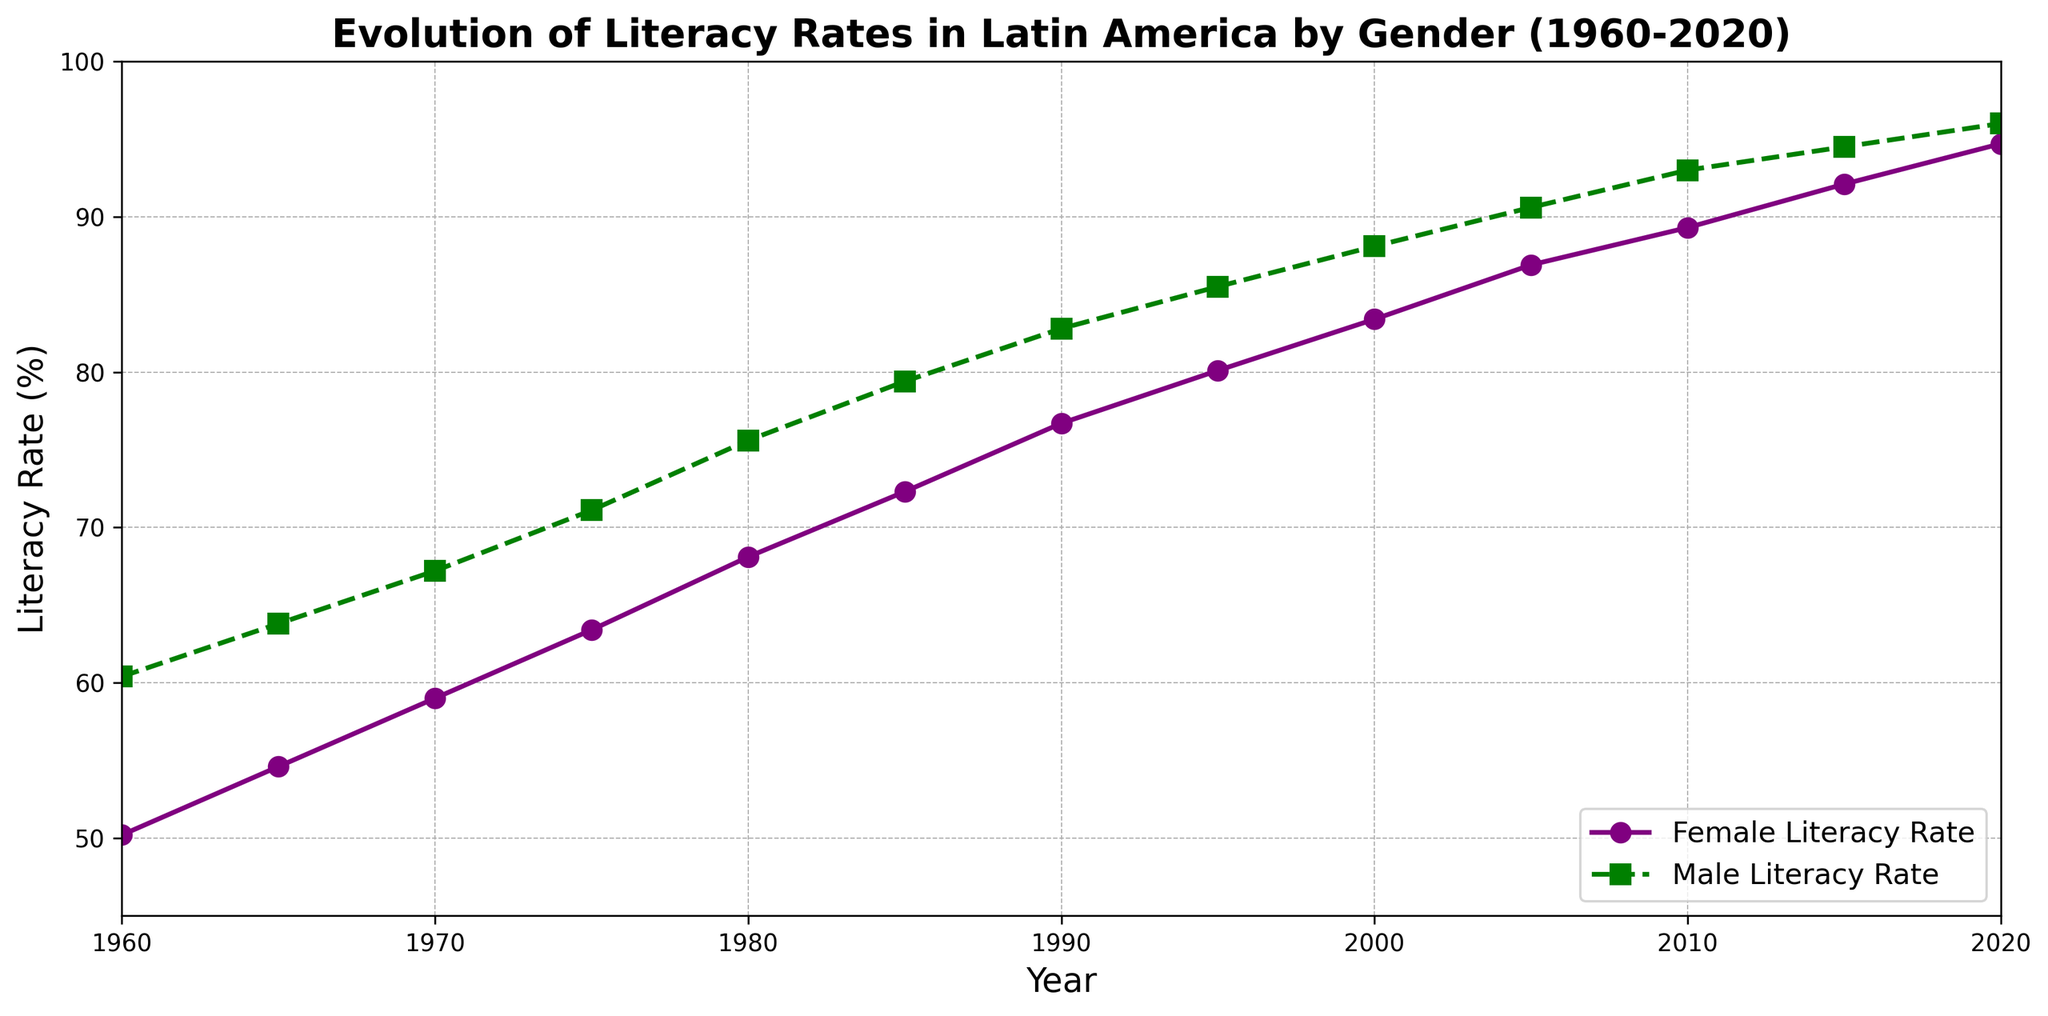What is the literacy rate gap between males and females in 1960? To find the literacy gap, subtract the female literacy rate from the male literacy rate in 1960. That is 60.4% - 50.2% = 10.2%.
Answer: 10.2% Which gender had a higher literacy rate in 1985, and by how much? Compare the literacy rates for males and females in 1985. The male literacy rate is 79.4% and the female literacy rate is 72.3%. Subtract the female rate from the male rate: 79.4% - 72.3% = 7.1%. Males had a higher rate by 7.1%.
Answer: Males by 7.1% How did the female literacy rate change from 2000 to 2010? Subtract the female literacy rate in 2000 from the rate in 2010. That is 89.3% - 83.4% = 5.9%.
Answer: Increased by 5.9% What was the average literacy rate for females in 1965 and 1970? Sum the female literacy rates for 1965 and 1970 and then divide by 2: (54.6% + 59.0%) / 2 = 56.8%.
Answer: 56.8% Between which consecutive years did male literacy rate increase the most? Look at the differences between consecutive years for the male literacy rate and find the maximum: 
(63.8% - 60.4% = 3.4% from 1960-1965, 
67.2% - 63.8% = 3.4% from 1965-1970, 
71.1% - 67.2% = 3.9% from 1970-1975, 
75.6% - 71.1% = 4.5% from 1975-1980, 
79.4% - 75.6% = 3.8% from 1980-1985, 
82.8% - 79.4% = 3.4% from 1985-1990, 
85.5% - 82.8% = 2.7% from 1990-1995, 
88.1% - 85.5% = 2.6% from 1995-2000, 
90.6% - 88.1% = 2.5% from 2000-2005, 
93.0% - 90.6% = 2.4% from 2005-2010, 
94.5% - 93.0% = 1.5% from 2010-2015, 
96.0% - 94.5% = 1.5% from 2015-2020). 
The most significant increase, 4.5%, occurred between 1975 and 1980.
Answer: 1975-1980 Calculate the overall increase in female literacy rate from 1960 to 2020. Subtract the female literacy rate in 1960 from the 2020 rate: 94.7% - 50.2% = 44.5%.
Answer: 44.5% What is the trend for the literacy gap between males and females over time? To observe the trend, notice how the gap decreases over the years. In 1960, it was 10.2%, and by 2020 it reduced to 1.3%. This indicates a trend of narrowing gap.
Answer: Narrowing gap In which year did female literacy rate first cross 80%? Examine the data and identify the year: Female literacy rate was 80.1% in 1995.
Answer: 1995 What is the range of female literacy rates displayed in the chart? Subtract the minimum female literacy rate from the maximum: 94.7% - 50.2% = 44.5%.
Answer: 44.5% Describe the visual difference in the line styles representing male and female literacy rates. The female literacy rate is represented by a solid purple line with circular markers, while the male literacy rate is shown with a dashed green line and square markers.
Answer: Solid purple line with circles for females; dashed green line with squares for males 